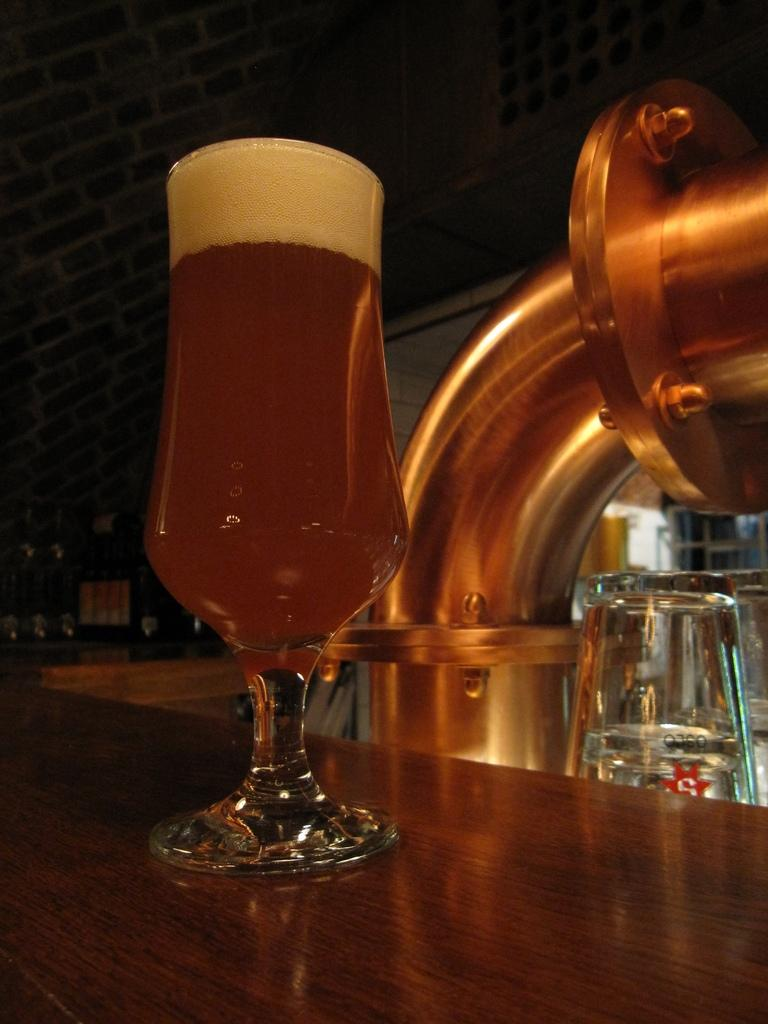What is present on the table in the image? There is a wine glass in the image. Where is the wine glass located? The wine glass is placed on a table. What type of salt can be seen on the branch in the image? There is no salt or branch present in the image; it only features a wine glass on a table. 